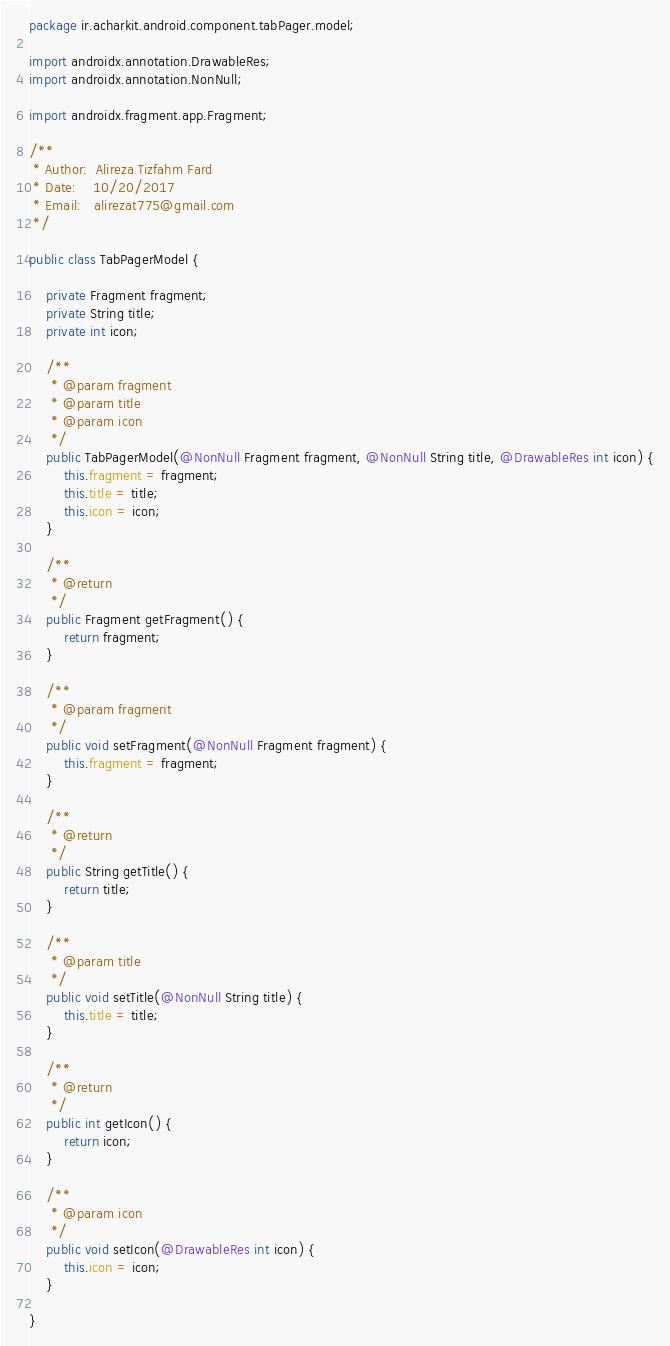Convert code to text. <code><loc_0><loc_0><loc_500><loc_500><_Java_>package ir.acharkit.android.component.tabPager.model;

import androidx.annotation.DrawableRes;
import androidx.annotation.NonNull;

import androidx.fragment.app.Fragment;

/**
 * Author:  Alireza Tizfahm Fard
 * Date:    10/20/2017
 * Email:   alirezat775@gmail.com
 */

public class TabPagerModel {

    private Fragment fragment;
    private String title;
    private int icon;

    /**
     * @param fragment
     * @param title
     * @param icon
     */
    public TabPagerModel(@NonNull Fragment fragment, @NonNull String title, @DrawableRes int icon) {
        this.fragment = fragment;
        this.title = title;
        this.icon = icon;
    }

    /**
     * @return
     */
    public Fragment getFragment() {
        return fragment;
    }

    /**
     * @param fragment
     */
    public void setFragment(@NonNull Fragment fragment) {
        this.fragment = fragment;
    }

    /**
     * @return
     */
    public String getTitle() {
        return title;
    }

    /**
     * @param title
     */
    public void setTitle(@NonNull String title) {
        this.title = title;
    }

    /**
     * @return
     */
    public int getIcon() {
        return icon;
    }

    /**
     * @param icon
     */
    public void setIcon(@DrawableRes int icon) {
        this.icon = icon;
    }

}
</code> 